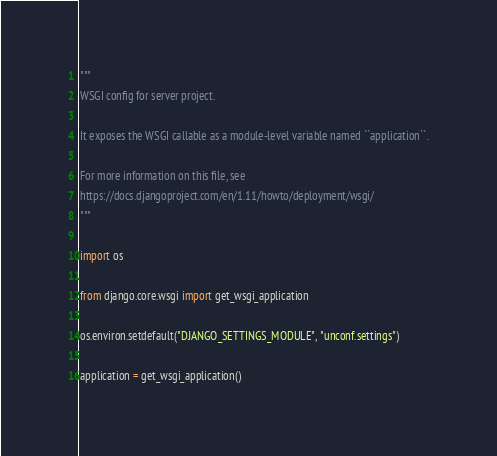<code> <loc_0><loc_0><loc_500><loc_500><_Python_>"""
WSGI config for server project.

It exposes the WSGI callable as a module-level variable named ``application``.

For more information on this file, see
https://docs.djangoproject.com/en/1.11/howto/deployment/wsgi/
"""

import os

from django.core.wsgi import get_wsgi_application

os.environ.setdefault("DJANGO_SETTINGS_MODULE", "unconf.settings")

application = get_wsgi_application()
</code> 